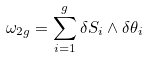<formula> <loc_0><loc_0><loc_500><loc_500>\omega _ { 2 g } = \sum _ { i = 1 } ^ { g } \delta S _ { i } \wedge \delta \theta _ { i }</formula> 